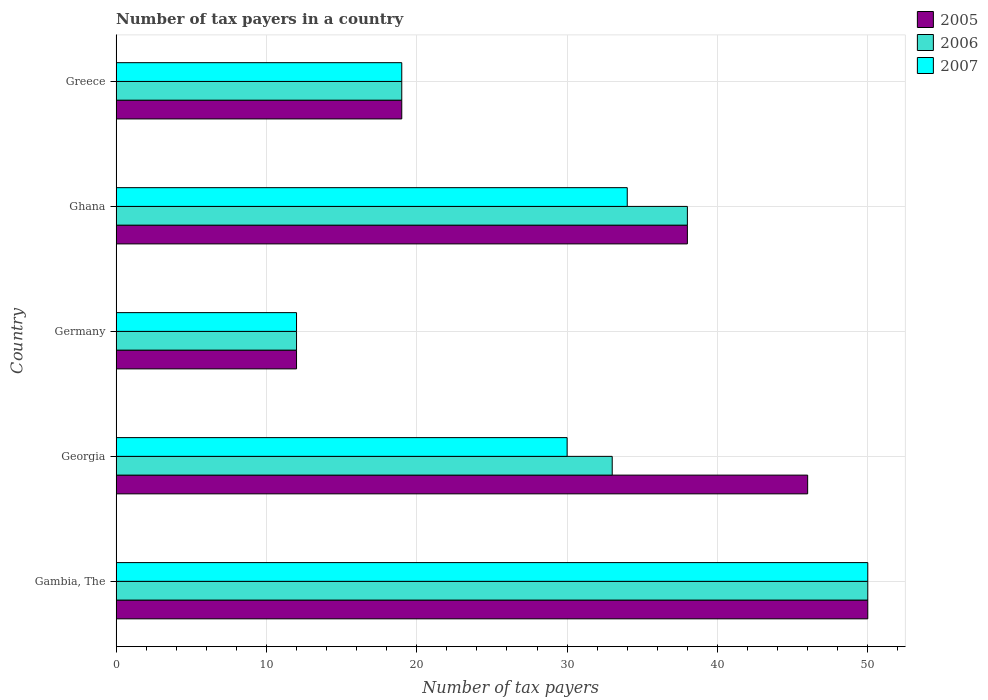How many bars are there on the 4th tick from the bottom?
Your answer should be very brief. 3. What is the label of the 3rd group of bars from the top?
Ensure brevity in your answer.  Germany. In how many cases, is the number of bars for a given country not equal to the number of legend labels?
Ensure brevity in your answer.  0. In which country was the number of tax payers in in 2006 maximum?
Your response must be concise. Gambia, The. What is the total number of tax payers in in 2005 in the graph?
Your answer should be compact. 165. What is the ratio of the number of tax payers in in 2005 in Gambia, The to that in Germany?
Make the answer very short. 4.17. Is the number of tax payers in in 2005 in Georgia less than that in Greece?
Give a very brief answer. No. Is the difference between the number of tax payers in in 2005 in Georgia and Greece greater than the difference between the number of tax payers in in 2006 in Georgia and Greece?
Your response must be concise. Yes. What is the difference between the highest and the second highest number of tax payers in in 2005?
Offer a terse response. 4. In how many countries, is the number of tax payers in in 2007 greater than the average number of tax payers in in 2007 taken over all countries?
Your answer should be very brief. 3. How many bars are there?
Keep it short and to the point. 15. Are all the bars in the graph horizontal?
Keep it short and to the point. Yes. How many countries are there in the graph?
Offer a very short reply. 5. What is the difference between two consecutive major ticks on the X-axis?
Give a very brief answer. 10. Are the values on the major ticks of X-axis written in scientific E-notation?
Your response must be concise. No. Does the graph contain any zero values?
Give a very brief answer. No. Does the graph contain grids?
Give a very brief answer. Yes. Where does the legend appear in the graph?
Your answer should be very brief. Top right. How many legend labels are there?
Offer a terse response. 3. How are the legend labels stacked?
Your response must be concise. Vertical. What is the title of the graph?
Offer a very short reply. Number of tax payers in a country. Does "1979" appear as one of the legend labels in the graph?
Make the answer very short. No. What is the label or title of the X-axis?
Provide a short and direct response. Number of tax payers. What is the label or title of the Y-axis?
Offer a very short reply. Country. What is the Number of tax payers in 2006 in Gambia, The?
Make the answer very short. 50. What is the Number of tax payers of 2006 in Georgia?
Keep it short and to the point. 33. What is the Number of tax payers of 2007 in Georgia?
Your answer should be very brief. 30. What is the Number of tax payers of 2007 in Ghana?
Provide a succinct answer. 34. What is the Number of tax payers of 2005 in Greece?
Offer a very short reply. 19. What is the Number of tax payers in 2007 in Greece?
Provide a succinct answer. 19. Across all countries, what is the maximum Number of tax payers in 2005?
Provide a short and direct response. 50. Across all countries, what is the minimum Number of tax payers of 2006?
Provide a short and direct response. 12. Across all countries, what is the minimum Number of tax payers in 2007?
Provide a short and direct response. 12. What is the total Number of tax payers of 2005 in the graph?
Keep it short and to the point. 165. What is the total Number of tax payers in 2006 in the graph?
Offer a very short reply. 152. What is the total Number of tax payers in 2007 in the graph?
Provide a succinct answer. 145. What is the difference between the Number of tax payers of 2007 in Gambia, The and that in Georgia?
Make the answer very short. 20. What is the difference between the Number of tax payers of 2005 in Gambia, The and that in Germany?
Offer a very short reply. 38. What is the difference between the Number of tax payers of 2006 in Gambia, The and that in Ghana?
Give a very brief answer. 12. What is the difference between the Number of tax payers of 2005 in Georgia and that in Germany?
Ensure brevity in your answer.  34. What is the difference between the Number of tax payers in 2007 in Georgia and that in Germany?
Provide a short and direct response. 18. What is the difference between the Number of tax payers of 2007 in Georgia and that in Ghana?
Ensure brevity in your answer.  -4. What is the difference between the Number of tax payers of 2007 in Georgia and that in Greece?
Your response must be concise. 11. What is the difference between the Number of tax payers of 2005 in Germany and that in Ghana?
Make the answer very short. -26. What is the difference between the Number of tax payers in 2007 in Germany and that in Greece?
Provide a short and direct response. -7. What is the difference between the Number of tax payers of 2005 in Ghana and that in Greece?
Your response must be concise. 19. What is the difference between the Number of tax payers in 2006 in Ghana and that in Greece?
Offer a very short reply. 19. What is the difference between the Number of tax payers in 2007 in Ghana and that in Greece?
Your response must be concise. 15. What is the difference between the Number of tax payers in 2005 in Gambia, The and the Number of tax payers in 2007 in Georgia?
Your response must be concise. 20. What is the difference between the Number of tax payers in 2006 in Gambia, The and the Number of tax payers in 2007 in Georgia?
Keep it short and to the point. 20. What is the difference between the Number of tax payers in 2005 in Gambia, The and the Number of tax payers in 2007 in Germany?
Offer a terse response. 38. What is the difference between the Number of tax payers in 2006 in Gambia, The and the Number of tax payers in 2007 in Germany?
Make the answer very short. 38. What is the difference between the Number of tax payers of 2005 in Gambia, The and the Number of tax payers of 2006 in Ghana?
Your answer should be very brief. 12. What is the difference between the Number of tax payers in 2005 in Georgia and the Number of tax payers in 2006 in Germany?
Offer a terse response. 34. What is the difference between the Number of tax payers in 2005 in Georgia and the Number of tax payers in 2007 in Germany?
Give a very brief answer. 34. What is the difference between the Number of tax payers in 2006 in Georgia and the Number of tax payers in 2007 in Germany?
Make the answer very short. 21. What is the difference between the Number of tax payers of 2005 in Georgia and the Number of tax payers of 2006 in Ghana?
Offer a terse response. 8. What is the difference between the Number of tax payers in 2005 in Georgia and the Number of tax payers in 2006 in Greece?
Provide a succinct answer. 27. What is the difference between the Number of tax payers of 2005 in Georgia and the Number of tax payers of 2007 in Greece?
Your response must be concise. 27. What is the difference between the Number of tax payers in 2006 in Georgia and the Number of tax payers in 2007 in Greece?
Your answer should be compact. 14. What is the difference between the Number of tax payers of 2006 in Germany and the Number of tax payers of 2007 in Ghana?
Provide a succinct answer. -22. What is the difference between the Number of tax payers in 2005 in Ghana and the Number of tax payers in 2006 in Greece?
Make the answer very short. 19. What is the difference between the Number of tax payers of 2006 in Ghana and the Number of tax payers of 2007 in Greece?
Provide a short and direct response. 19. What is the average Number of tax payers in 2006 per country?
Offer a terse response. 30.4. What is the difference between the Number of tax payers in 2005 and Number of tax payers in 2007 in Gambia, The?
Keep it short and to the point. 0. What is the difference between the Number of tax payers of 2005 and Number of tax payers of 2006 in Georgia?
Your answer should be compact. 13. What is the difference between the Number of tax payers of 2005 and Number of tax payers of 2007 in Georgia?
Give a very brief answer. 16. What is the difference between the Number of tax payers in 2005 and Number of tax payers in 2007 in Ghana?
Give a very brief answer. 4. What is the difference between the Number of tax payers of 2006 and Number of tax payers of 2007 in Ghana?
Offer a very short reply. 4. What is the difference between the Number of tax payers of 2005 and Number of tax payers of 2006 in Greece?
Your response must be concise. 0. What is the difference between the Number of tax payers in 2006 and Number of tax payers in 2007 in Greece?
Offer a very short reply. 0. What is the ratio of the Number of tax payers of 2005 in Gambia, The to that in Georgia?
Your answer should be very brief. 1.09. What is the ratio of the Number of tax payers in 2006 in Gambia, The to that in Georgia?
Offer a very short reply. 1.52. What is the ratio of the Number of tax payers in 2007 in Gambia, The to that in Georgia?
Your answer should be very brief. 1.67. What is the ratio of the Number of tax payers of 2005 in Gambia, The to that in Germany?
Offer a terse response. 4.17. What is the ratio of the Number of tax payers in 2006 in Gambia, The to that in Germany?
Your answer should be very brief. 4.17. What is the ratio of the Number of tax payers in 2007 in Gambia, The to that in Germany?
Provide a short and direct response. 4.17. What is the ratio of the Number of tax payers of 2005 in Gambia, The to that in Ghana?
Ensure brevity in your answer.  1.32. What is the ratio of the Number of tax payers in 2006 in Gambia, The to that in Ghana?
Provide a short and direct response. 1.32. What is the ratio of the Number of tax payers in 2007 in Gambia, The to that in Ghana?
Provide a short and direct response. 1.47. What is the ratio of the Number of tax payers of 2005 in Gambia, The to that in Greece?
Provide a short and direct response. 2.63. What is the ratio of the Number of tax payers in 2006 in Gambia, The to that in Greece?
Offer a terse response. 2.63. What is the ratio of the Number of tax payers in 2007 in Gambia, The to that in Greece?
Make the answer very short. 2.63. What is the ratio of the Number of tax payers of 2005 in Georgia to that in Germany?
Provide a succinct answer. 3.83. What is the ratio of the Number of tax payers of 2006 in Georgia to that in Germany?
Ensure brevity in your answer.  2.75. What is the ratio of the Number of tax payers in 2005 in Georgia to that in Ghana?
Provide a short and direct response. 1.21. What is the ratio of the Number of tax payers of 2006 in Georgia to that in Ghana?
Your answer should be compact. 0.87. What is the ratio of the Number of tax payers in 2007 in Georgia to that in Ghana?
Offer a very short reply. 0.88. What is the ratio of the Number of tax payers in 2005 in Georgia to that in Greece?
Make the answer very short. 2.42. What is the ratio of the Number of tax payers of 2006 in Georgia to that in Greece?
Ensure brevity in your answer.  1.74. What is the ratio of the Number of tax payers of 2007 in Georgia to that in Greece?
Provide a short and direct response. 1.58. What is the ratio of the Number of tax payers of 2005 in Germany to that in Ghana?
Offer a terse response. 0.32. What is the ratio of the Number of tax payers in 2006 in Germany to that in Ghana?
Make the answer very short. 0.32. What is the ratio of the Number of tax payers of 2007 in Germany to that in Ghana?
Keep it short and to the point. 0.35. What is the ratio of the Number of tax payers of 2005 in Germany to that in Greece?
Keep it short and to the point. 0.63. What is the ratio of the Number of tax payers in 2006 in Germany to that in Greece?
Offer a terse response. 0.63. What is the ratio of the Number of tax payers of 2007 in Germany to that in Greece?
Your answer should be very brief. 0.63. What is the ratio of the Number of tax payers in 2005 in Ghana to that in Greece?
Provide a succinct answer. 2. What is the ratio of the Number of tax payers of 2007 in Ghana to that in Greece?
Offer a terse response. 1.79. What is the difference between the highest and the second highest Number of tax payers of 2005?
Ensure brevity in your answer.  4. What is the difference between the highest and the lowest Number of tax payers of 2006?
Provide a succinct answer. 38. 